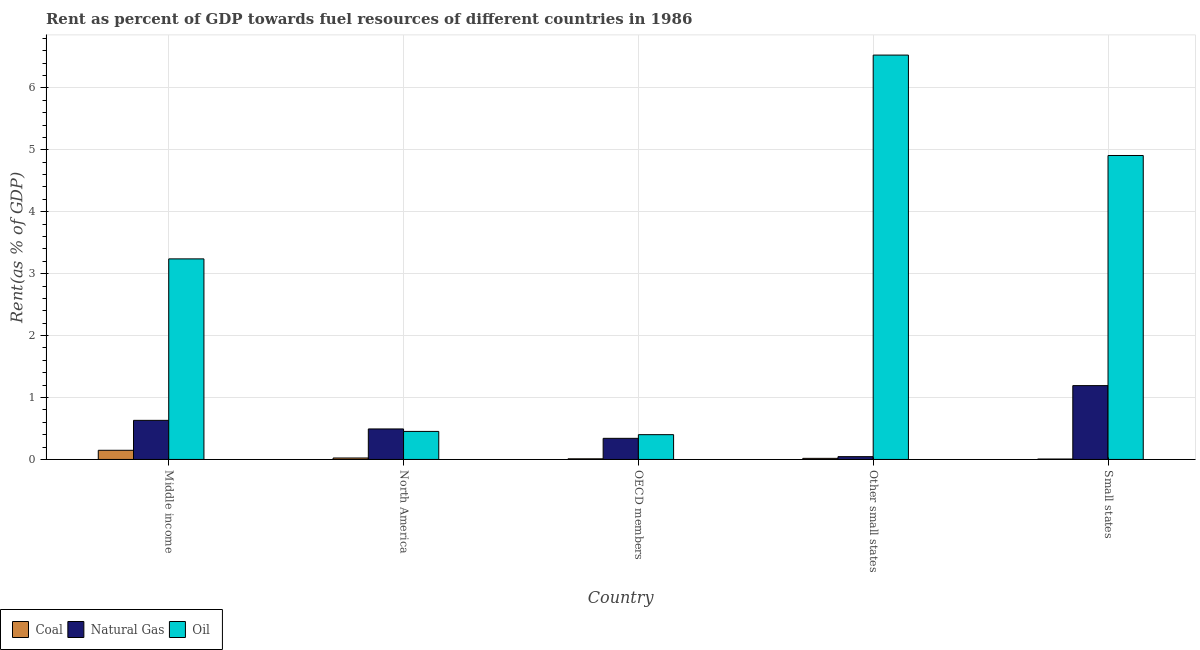How many groups of bars are there?
Provide a short and direct response. 5. How many bars are there on the 4th tick from the left?
Give a very brief answer. 3. What is the label of the 1st group of bars from the left?
Your answer should be compact. Middle income. What is the rent towards oil in Middle income?
Your response must be concise. 3.24. Across all countries, what is the maximum rent towards coal?
Give a very brief answer. 0.15. Across all countries, what is the minimum rent towards coal?
Give a very brief answer. 0.01. In which country was the rent towards coal maximum?
Give a very brief answer. Middle income. What is the total rent towards oil in the graph?
Your response must be concise. 15.53. What is the difference between the rent towards natural gas in OECD members and that in Other small states?
Keep it short and to the point. 0.3. What is the difference between the rent towards coal in OECD members and the rent towards natural gas in North America?
Offer a very short reply. -0.48. What is the average rent towards oil per country?
Keep it short and to the point. 3.11. What is the difference between the rent towards coal and rent towards oil in Middle income?
Your response must be concise. -3.09. In how many countries, is the rent towards oil greater than 2.4 %?
Your answer should be compact. 3. What is the ratio of the rent towards coal in North America to that in Small states?
Make the answer very short. 3.44. Is the rent towards coal in North America less than that in Small states?
Your answer should be very brief. No. Is the difference between the rent towards coal in North America and Other small states greater than the difference between the rent towards natural gas in North America and Other small states?
Ensure brevity in your answer.  No. What is the difference between the highest and the second highest rent towards coal?
Make the answer very short. 0.12. What is the difference between the highest and the lowest rent towards coal?
Give a very brief answer. 0.14. In how many countries, is the rent towards coal greater than the average rent towards coal taken over all countries?
Offer a terse response. 1. What does the 2nd bar from the left in Middle income represents?
Provide a succinct answer. Natural Gas. What does the 2nd bar from the right in Other small states represents?
Offer a very short reply. Natural Gas. Is it the case that in every country, the sum of the rent towards coal and rent towards natural gas is greater than the rent towards oil?
Offer a terse response. No. How many bars are there?
Provide a short and direct response. 15. Are all the bars in the graph horizontal?
Make the answer very short. No. How many countries are there in the graph?
Your answer should be very brief. 5. Are the values on the major ticks of Y-axis written in scientific E-notation?
Provide a succinct answer. No. Where does the legend appear in the graph?
Keep it short and to the point. Bottom left. How many legend labels are there?
Provide a short and direct response. 3. What is the title of the graph?
Make the answer very short. Rent as percent of GDP towards fuel resources of different countries in 1986. Does "Other sectors" appear as one of the legend labels in the graph?
Give a very brief answer. No. What is the label or title of the Y-axis?
Provide a succinct answer. Rent(as % of GDP). What is the Rent(as % of GDP) of Coal in Middle income?
Your answer should be compact. 0.15. What is the Rent(as % of GDP) in Natural Gas in Middle income?
Offer a very short reply. 0.63. What is the Rent(as % of GDP) in Oil in Middle income?
Offer a very short reply. 3.24. What is the Rent(as % of GDP) of Coal in North America?
Provide a short and direct response. 0.02. What is the Rent(as % of GDP) of Natural Gas in North America?
Provide a short and direct response. 0.49. What is the Rent(as % of GDP) in Oil in North America?
Make the answer very short. 0.45. What is the Rent(as % of GDP) of Coal in OECD members?
Your answer should be compact. 0.01. What is the Rent(as % of GDP) of Natural Gas in OECD members?
Your answer should be very brief. 0.34. What is the Rent(as % of GDP) of Oil in OECD members?
Give a very brief answer. 0.4. What is the Rent(as % of GDP) in Coal in Other small states?
Offer a terse response. 0.02. What is the Rent(as % of GDP) in Natural Gas in Other small states?
Make the answer very short. 0.05. What is the Rent(as % of GDP) in Oil in Other small states?
Your answer should be compact. 6.53. What is the Rent(as % of GDP) in Coal in Small states?
Offer a terse response. 0.01. What is the Rent(as % of GDP) of Natural Gas in Small states?
Your answer should be compact. 1.19. What is the Rent(as % of GDP) of Oil in Small states?
Provide a short and direct response. 4.91. Across all countries, what is the maximum Rent(as % of GDP) of Coal?
Give a very brief answer. 0.15. Across all countries, what is the maximum Rent(as % of GDP) in Natural Gas?
Offer a very short reply. 1.19. Across all countries, what is the maximum Rent(as % of GDP) of Oil?
Offer a terse response. 6.53. Across all countries, what is the minimum Rent(as % of GDP) of Coal?
Offer a very short reply. 0.01. Across all countries, what is the minimum Rent(as % of GDP) in Natural Gas?
Offer a very short reply. 0.05. Across all countries, what is the minimum Rent(as % of GDP) in Oil?
Keep it short and to the point. 0.4. What is the total Rent(as % of GDP) of Coal in the graph?
Your answer should be very brief. 0.21. What is the total Rent(as % of GDP) of Natural Gas in the graph?
Make the answer very short. 2.7. What is the total Rent(as % of GDP) of Oil in the graph?
Your answer should be very brief. 15.53. What is the difference between the Rent(as % of GDP) in Coal in Middle income and that in North America?
Give a very brief answer. 0.12. What is the difference between the Rent(as % of GDP) in Natural Gas in Middle income and that in North America?
Provide a succinct answer. 0.14. What is the difference between the Rent(as % of GDP) of Oil in Middle income and that in North America?
Ensure brevity in your answer.  2.79. What is the difference between the Rent(as % of GDP) in Coal in Middle income and that in OECD members?
Offer a very short reply. 0.14. What is the difference between the Rent(as % of GDP) of Natural Gas in Middle income and that in OECD members?
Offer a terse response. 0.29. What is the difference between the Rent(as % of GDP) of Oil in Middle income and that in OECD members?
Provide a succinct answer. 2.84. What is the difference between the Rent(as % of GDP) in Coal in Middle income and that in Other small states?
Your response must be concise. 0.13. What is the difference between the Rent(as % of GDP) in Natural Gas in Middle income and that in Other small states?
Give a very brief answer. 0.59. What is the difference between the Rent(as % of GDP) in Oil in Middle income and that in Other small states?
Offer a terse response. -3.29. What is the difference between the Rent(as % of GDP) in Coal in Middle income and that in Small states?
Make the answer very short. 0.14. What is the difference between the Rent(as % of GDP) in Natural Gas in Middle income and that in Small states?
Provide a short and direct response. -0.56. What is the difference between the Rent(as % of GDP) of Oil in Middle income and that in Small states?
Provide a short and direct response. -1.67. What is the difference between the Rent(as % of GDP) of Coal in North America and that in OECD members?
Make the answer very short. 0.01. What is the difference between the Rent(as % of GDP) in Natural Gas in North America and that in OECD members?
Your answer should be very brief. 0.15. What is the difference between the Rent(as % of GDP) of Oil in North America and that in OECD members?
Provide a succinct answer. 0.05. What is the difference between the Rent(as % of GDP) of Coal in North America and that in Other small states?
Make the answer very short. 0.01. What is the difference between the Rent(as % of GDP) in Natural Gas in North America and that in Other small states?
Ensure brevity in your answer.  0.45. What is the difference between the Rent(as % of GDP) of Oil in North America and that in Other small states?
Your response must be concise. -6.08. What is the difference between the Rent(as % of GDP) of Coal in North America and that in Small states?
Provide a succinct answer. 0.02. What is the difference between the Rent(as % of GDP) of Natural Gas in North America and that in Small states?
Provide a succinct answer. -0.7. What is the difference between the Rent(as % of GDP) in Oil in North America and that in Small states?
Make the answer very short. -4.46. What is the difference between the Rent(as % of GDP) in Coal in OECD members and that in Other small states?
Provide a short and direct response. -0.01. What is the difference between the Rent(as % of GDP) of Natural Gas in OECD members and that in Other small states?
Your answer should be compact. 0.3. What is the difference between the Rent(as % of GDP) in Oil in OECD members and that in Other small states?
Offer a terse response. -6.13. What is the difference between the Rent(as % of GDP) of Coal in OECD members and that in Small states?
Your answer should be very brief. 0. What is the difference between the Rent(as % of GDP) in Natural Gas in OECD members and that in Small states?
Offer a terse response. -0.85. What is the difference between the Rent(as % of GDP) in Oil in OECD members and that in Small states?
Provide a short and direct response. -4.51. What is the difference between the Rent(as % of GDP) in Coal in Other small states and that in Small states?
Give a very brief answer. 0.01. What is the difference between the Rent(as % of GDP) of Natural Gas in Other small states and that in Small states?
Offer a terse response. -1.15. What is the difference between the Rent(as % of GDP) in Oil in Other small states and that in Small states?
Make the answer very short. 1.62. What is the difference between the Rent(as % of GDP) in Coal in Middle income and the Rent(as % of GDP) in Natural Gas in North America?
Offer a terse response. -0.34. What is the difference between the Rent(as % of GDP) of Coal in Middle income and the Rent(as % of GDP) of Oil in North America?
Provide a short and direct response. -0.3. What is the difference between the Rent(as % of GDP) in Natural Gas in Middle income and the Rent(as % of GDP) in Oil in North America?
Your answer should be compact. 0.18. What is the difference between the Rent(as % of GDP) of Coal in Middle income and the Rent(as % of GDP) of Natural Gas in OECD members?
Offer a terse response. -0.19. What is the difference between the Rent(as % of GDP) of Coal in Middle income and the Rent(as % of GDP) of Oil in OECD members?
Keep it short and to the point. -0.25. What is the difference between the Rent(as % of GDP) in Natural Gas in Middle income and the Rent(as % of GDP) in Oil in OECD members?
Make the answer very short. 0.23. What is the difference between the Rent(as % of GDP) in Coal in Middle income and the Rent(as % of GDP) in Natural Gas in Other small states?
Give a very brief answer. 0.1. What is the difference between the Rent(as % of GDP) in Coal in Middle income and the Rent(as % of GDP) in Oil in Other small states?
Make the answer very short. -6.38. What is the difference between the Rent(as % of GDP) in Natural Gas in Middle income and the Rent(as % of GDP) in Oil in Other small states?
Your response must be concise. -5.9. What is the difference between the Rent(as % of GDP) in Coal in Middle income and the Rent(as % of GDP) in Natural Gas in Small states?
Your answer should be compact. -1.04. What is the difference between the Rent(as % of GDP) in Coal in Middle income and the Rent(as % of GDP) in Oil in Small states?
Give a very brief answer. -4.76. What is the difference between the Rent(as % of GDP) in Natural Gas in Middle income and the Rent(as % of GDP) in Oil in Small states?
Make the answer very short. -4.28. What is the difference between the Rent(as % of GDP) in Coal in North America and the Rent(as % of GDP) in Natural Gas in OECD members?
Offer a very short reply. -0.32. What is the difference between the Rent(as % of GDP) of Coal in North America and the Rent(as % of GDP) of Oil in OECD members?
Offer a terse response. -0.38. What is the difference between the Rent(as % of GDP) in Natural Gas in North America and the Rent(as % of GDP) in Oil in OECD members?
Your answer should be very brief. 0.09. What is the difference between the Rent(as % of GDP) in Coal in North America and the Rent(as % of GDP) in Natural Gas in Other small states?
Provide a succinct answer. -0.02. What is the difference between the Rent(as % of GDP) of Coal in North America and the Rent(as % of GDP) of Oil in Other small states?
Ensure brevity in your answer.  -6.51. What is the difference between the Rent(as % of GDP) in Natural Gas in North America and the Rent(as % of GDP) in Oil in Other small states?
Your answer should be compact. -6.04. What is the difference between the Rent(as % of GDP) in Coal in North America and the Rent(as % of GDP) in Natural Gas in Small states?
Your response must be concise. -1.17. What is the difference between the Rent(as % of GDP) in Coal in North America and the Rent(as % of GDP) in Oil in Small states?
Offer a very short reply. -4.88. What is the difference between the Rent(as % of GDP) in Natural Gas in North America and the Rent(as % of GDP) in Oil in Small states?
Your answer should be very brief. -4.42. What is the difference between the Rent(as % of GDP) in Coal in OECD members and the Rent(as % of GDP) in Natural Gas in Other small states?
Provide a succinct answer. -0.04. What is the difference between the Rent(as % of GDP) of Coal in OECD members and the Rent(as % of GDP) of Oil in Other small states?
Offer a very short reply. -6.52. What is the difference between the Rent(as % of GDP) in Natural Gas in OECD members and the Rent(as % of GDP) in Oil in Other small states?
Give a very brief answer. -6.19. What is the difference between the Rent(as % of GDP) of Coal in OECD members and the Rent(as % of GDP) of Natural Gas in Small states?
Give a very brief answer. -1.18. What is the difference between the Rent(as % of GDP) in Coal in OECD members and the Rent(as % of GDP) in Oil in Small states?
Keep it short and to the point. -4.9. What is the difference between the Rent(as % of GDP) of Natural Gas in OECD members and the Rent(as % of GDP) of Oil in Small states?
Give a very brief answer. -4.57. What is the difference between the Rent(as % of GDP) in Coal in Other small states and the Rent(as % of GDP) in Natural Gas in Small states?
Provide a succinct answer. -1.17. What is the difference between the Rent(as % of GDP) in Coal in Other small states and the Rent(as % of GDP) in Oil in Small states?
Give a very brief answer. -4.89. What is the difference between the Rent(as % of GDP) of Natural Gas in Other small states and the Rent(as % of GDP) of Oil in Small states?
Your response must be concise. -4.86. What is the average Rent(as % of GDP) of Coal per country?
Make the answer very short. 0.04. What is the average Rent(as % of GDP) of Natural Gas per country?
Give a very brief answer. 0.54. What is the average Rent(as % of GDP) of Oil per country?
Provide a short and direct response. 3.11. What is the difference between the Rent(as % of GDP) of Coal and Rent(as % of GDP) of Natural Gas in Middle income?
Ensure brevity in your answer.  -0.48. What is the difference between the Rent(as % of GDP) of Coal and Rent(as % of GDP) of Oil in Middle income?
Your answer should be compact. -3.09. What is the difference between the Rent(as % of GDP) in Natural Gas and Rent(as % of GDP) in Oil in Middle income?
Provide a succinct answer. -2.61. What is the difference between the Rent(as % of GDP) in Coal and Rent(as % of GDP) in Natural Gas in North America?
Provide a succinct answer. -0.47. What is the difference between the Rent(as % of GDP) of Coal and Rent(as % of GDP) of Oil in North America?
Make the answer very short. -0.43. What is the difference between the Rent(as % of GDP) of Natural Gas and Rent(as % of GDP) of Oil in North America?
Keep it short and to the point. 0.04. What is the difference between the Rent(as % of GDP) of Coal and Rent(as % of GDP) of Natural Gas in OECD members?
Your answer should be very brief. -0.33. What is the difference between the Rent(as % of GDP) in Coal and Rent(as % of GDP) in Oil in OECD members?
Ensure brevity in your answer.  -0.39. What is the difference between the Rent(as % of GDP) of Natural Gas and Rent(as % of GDP) of Oil in OECD members?
Give a very brief answer. -0.06. What is the difference between the Rent(as % of GDP) in Coal and Rent(as % of GDP) in Natural Gas in Other small states?
Keep it short and to the point. -0.03. What is the difference between the Rent(as % of GDP) in Coal and Rent(as % of GDP) in Oil in Other small states?
Offer a terse response. -6.51. What is the difference between the Rent(as % of GDP) in Natural Gas and Rent(as % of GDP) in Oil in Other small states?
Your answer should be very brief. -6.48. What is the difference between the Rent(as % of GDP) in Coal and Rent(as % of GDP) in Natural Gas in Small states?
Your response must be concise. -1.19. What is the difference between the Rent(as % of GDP) in Coal and Rent(as % of GDP) in Oil in Small states?
Keep it short and to the point. -4.9. What is the difference between the Rent(as % of GDP) of Natural Gas and Rent(as % of GDP) of Oil in Small states?
Keep it short and to the point. -3.72. What is the ratio of the Rent(as % of GDP) in Coal in Middle income to that in North America?
Your answer should be compact. 6.29. What is the ratio of the Rent(as % of GDP) in Natural Gas in Middle income to that in North America?
Offer a terse response. 1.28. What is the ratio of the Rent(as % of GDP) in Oil in Middle income to that in North America?
Make the answer very short. 7.15. What is the ratio of the Rent(as % of GDP) of Coal in Middle income to that in OECD members?
Give a very brief answer. 14.53. What is the ratio of the Rent(as % of GDP) of Natural Gas in Middle income to that in OECD members?
Keep it short and to the point. 1.85. What is the ratio of the Rent(as % of GDP) in Oil in Middle income to that in OECD members?
Ensure brevity in your answer.  8.09. What is the ratio of the Rent(as % of GDP) of Coal in Middle income to that in Other small states?
Make the answer very short. 8.33. What is the ratio of the Rent(as % of GDP) in Natural Gas in Middle income to that in Other small states?
Your answer should be very brief. 13.93. What is the ratio of the Rent(as % of GDP) of Oil in Middle income to that in Other small states?
Ensure brevity in your answer.  0.5. What is the ratio of the Rent(as % of GDP) of Coal in Middle income to that in Small states?
Make the answer very short. 21.66. What is the ratio of the Rent(as % of GDP) in Natural Gas in Middle income to that in Small states?
Ensure brevity in your answer.  0.53. What is the ratio of the Rent(as % of GDP) in Oil in Middle income to that in Small states?
Give a very brief answer. 0.66. What is the ratio of the Rent(as % of GDP) of Coal in North America to that in OECD members?
Keep it short and to the point. 2.31. What is the ratio of the Rent(as % of GDP) of Natural Gas in North America to that in OECD members?
Your answer should be very brief. 1.44. What is the ratio of the Rent(as % of GDP) in Oil in North America to that in OECD members?
Ensure brevity in your answer.  1.13. What is the ratio of the Rent(as % of GDP) of Coal in North America to that in Other small states?
Keep it short and to the point. 1.32. What is the ratio of the Rent(as % of GDP) of Natural Gas in North America to that in Other small states?
Ensure brevity in your answer.  10.86. What is the ratio of the Rent(as % of GDP) of Oil in North America to that in Other small states?
Your answer should be compact. 0.07. What is the ratio of the Rent(as % of GDP) in Coal in North America to that in Small states?
Your response must be concise. 3.44. What is the ratio of the Rent(as % of GDP) of Natural Gas in North America to that in Small states?
Ensure brevity in your answer.  0.41. What is the ratio of the Rent(as % of GDP) in Oil in North America to that in Small states?
Your response must be concise. 0.09. What is the ratio of the Rent(as % of GDP) in Coal in OECD members to that in Other small states?
Give a very brief answer. 0.57. What is the ratio of the Rent(as % of GDP) of Natural Gas in OECD members to that in Other small states?
Provide a short and direct response. 7.52. What is the ratio of the Rent(as % of GDP) in Oil in OECD members to that in Other small states?
Your answer should be compact. 0.06. What is the ratio of the Rent(as % of GDP) in Coal in OECD members to that in Small states?
Give a very brief answer. 1.49. What is the ratio of the Rent(as % of GDP) in Natural Gas in OECD members to that in Small states?
Your response must be concise. 0.29. What is the ratio of the Rent(as % of GDP) in Oil in OECD members to that in Small states?
Make the answer very short. 0.08. What is the ratio of the Rent(as % of GDP) of Coal in Other small states to that in Small states?
Make the answer very short. 2.6. What is the ratio of the Rent(as % of GDP) of Natural Gas in Other small states to that in Small states?
Your answer should be very brief. 0.04. What is the ratio of the Rent(as % of GDP) in Oil in Other small states to that in Small states?
Provide a succinct answer. 1.33. What is the difference between the highest and the second highest Rent(as % of GDP) of Coal?
Your answer should be very brief. 0.12. What is the difference between the highest and the second highest Rent(as % of GDP) of Natural Gas?
Keep it short and to the point. 0.56. What is the difference between the highest and the second highest Rent(as % of GDP) of Oil?
Ensure brevity in your answer.  1.62. What is the difference between the highest and the lowest Rent(as % of GDP) of Coal?
Provide a succinct answer. 0.14. What is the difference between the highest and the lowest Rent(as % of GDP) of Natural Gas?
Provide a short and direct response. 1.15. What is the difference between the highest and the lowest Rent(as % of GDP) in Oil?
Give a very brief answer. 6.13. 